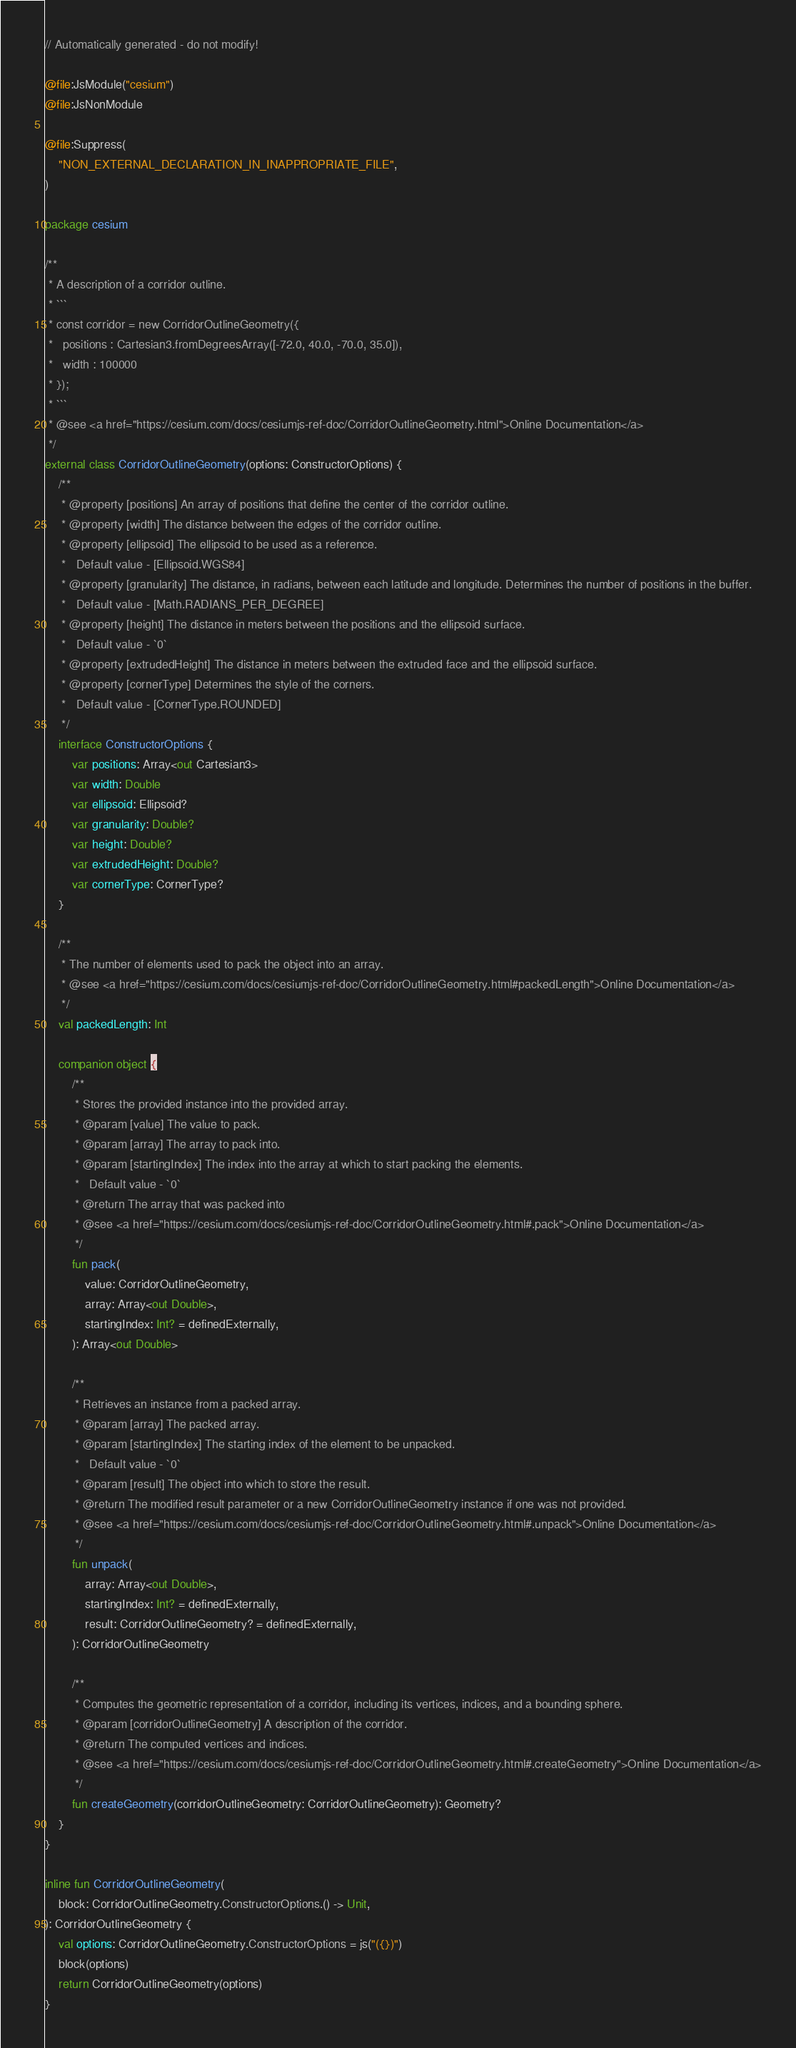Convert code to text. <code><loc_0><loc_0><loc_500><loc_500><_Kotlin_>// Automatically generated - do not modify!

@file:JsModule("cesium")
@file:JsNonModule

@file:Suppress(
    "NON_EXTERNAL_DECLARATION_IN_INAPPROPRIATE_FILE",
)

package cesium

/**
 * A description of a corridor outline.
 * ```
 * const corridor = new CorridorOutlineGeometry({
 *   positions : Cartesian3.fromDegreesArray([-72.0, 40.0, -70.0, 35.0]),
 *   width : 100000
 * });
 * ```
 * @see <a href="https://cesium.com/docs/cesiumjs-ref-doc/CorridorOutlineGeometry.html">Online Documentation</a>
 */
external class CorridorOutlineGeometry(options: ConstructorOptions) {
    /**
     * @property [positions] An array of positions that define the center of the corridor outline.
     * @property [width] The distance between the edges of the corridor outline.
     * @property [ellipsoid] The ellipsoid to be used as a reference.
     *   Default value - [Ellipsoid.WGS84]
     * @property [granularity] The distance, in radians, between each latitude and longitude. Determines the number of positions in the buffer.
     *   Default value - [Math.RADIANS_PER_DEGREE]
     * @property [height] The distance in meters between the positions and the ellipsoid surface.
     *   Default value - `0`
     * @property [extrudedHeight] The distance in meters between the extruded face and the ellipsoid surface.
     * @property [cornerType] Determines the style of the corners.
     *   Default value - [CornerType.ROUNDED]
     */
    interface ConstructorOptions {
        var positions: Array<out Cartesian3>
        var width: Double
        var ellipsoid: Ellipsoid?
        var granularity: Double?
        var height: Double?
        var extrudedHeight: Double?
        var cornerType: CornerType?
    }

    /**
     * The number of elements used to pack the object into an array.
     * @see <a href="https://cesium.com/docs/cesiumjs-ref-doc/CorridorOutlineGeometry.html#packedLength">Online Documentation</a>
     */
    val packedLength: Int

    companion object {
        /**
         * Stores the provided instance into the provided array.
         * @param [value] The value to pack.
         * @param [array] The array to pack into.
         * @param [startingIndex] The index into the array at which to start packing the elements.
         *   Default value - `0`
         * @return The array that was packed into
         * @see <a href="https://cesium.com/docs/cesiumjs-ref-doc/CorridorOutlineGeometry.html#.pack">Online Documentation</a>
         */
        fun pack(
            value: CorridorOutlineGeometry,
            array: Array<out Double>,
            startingIndex: Int? = definedExternally,
        ): Array<out Double>

        /**
         * Retrieves an instance from a packed array.
         * @param [array] The packed array.
         * @param [startingIndex] The starting index of the element to be unpacked.
         *   Default value - `0`
         * @param [result] The object into which to store the result.
         * @return The modified result parameter or a new CorridorOutlineGeometry instance if one was not provided.
         * @see <a href="https://cesium.com/docs/cesiumjs-ref-doc/CorridorOutlineGeometry.html#.unpack">Online Documentation</a>
         */
        fun unpack(
            array: Array<out Double>,
            startingIndex: Int? = definedExternally,
            result: CorridorOutlineGeometry? = definedExternally,
        ): CorridorOutlineGeometry

        /**
         * Computes the geometric representation of a corridor, including its vertices, indices, and a bounding sphere.
         * @param [corridorOutlineGeometry] A description of the corridor.
         * @return The computed vertices and indices.
         * @see <a href="https://cesium.com/docs/cesiumjs-ref-doc/CorridorOutlineGeometry.html#.createGeometry">Online Documentation</a>
         */
        fun createGeometry(corridorOutlineGeometry: CorridorOutlineGeometry): Geometry?
    }
}

inline fun CorridorOutlineGeometry(
    block: CorridorOutlineGeometry.ConstructorOptions.() -> Unit,
): CorridorOutlineGeometry {
    val options: CorridorOutlineGeometry.ConstructorOptions = js("({})")
    block(options)
    return CorridorOutlineGeometry(options)
}
</code> 